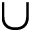<formula> <loc_0><loc_0><loc_500><loc_500>\cup</formula> 